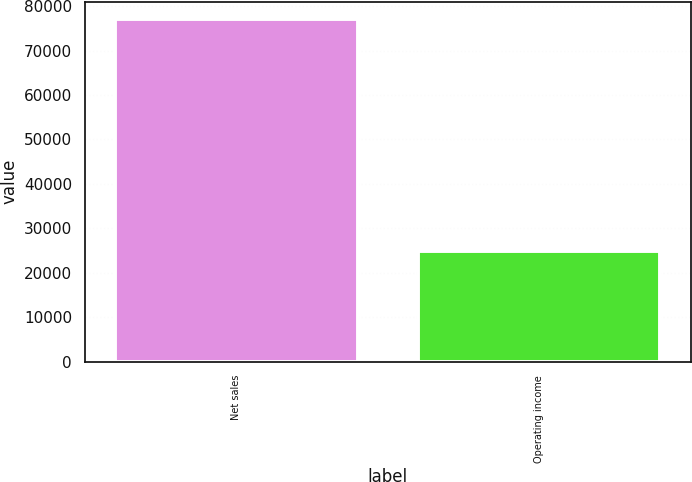Convert chart. <chart><loc_0><loc_0><loc_500><loc_500><bar_chart><fcel>Net sales<fcel>Operating income<nl><fcel>77093<fcel>24829<nl></chart> 